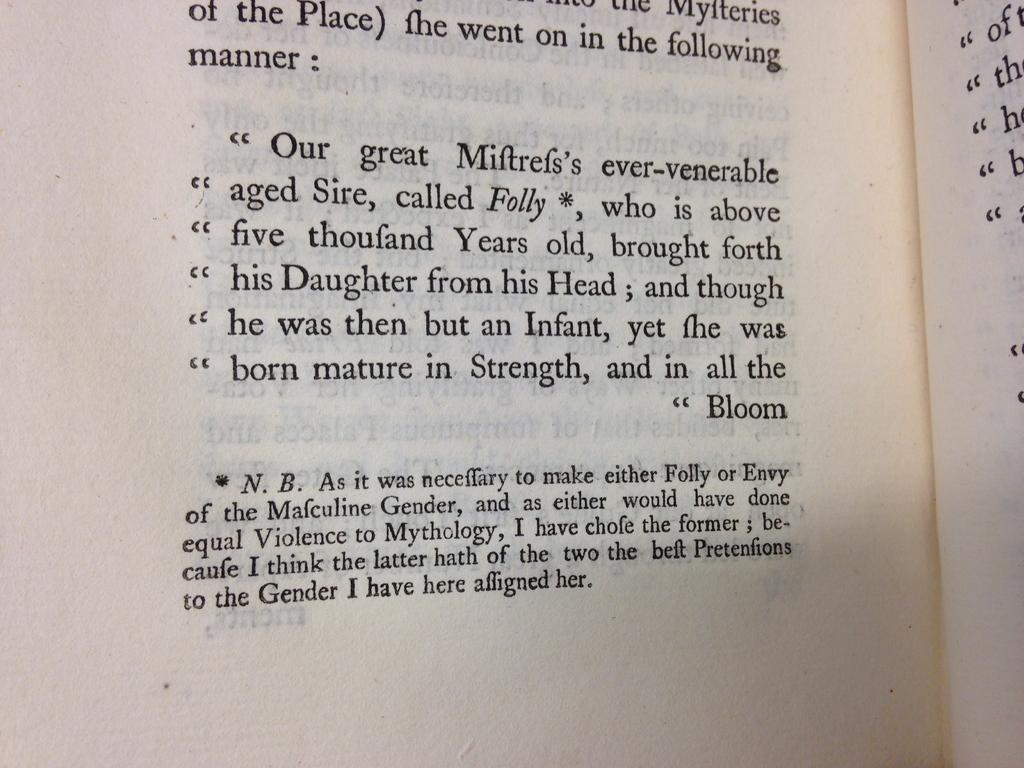<image>
Render a clear and concise summary of the photo. A book includes a footnote about choosing genders for different mythological characters. 